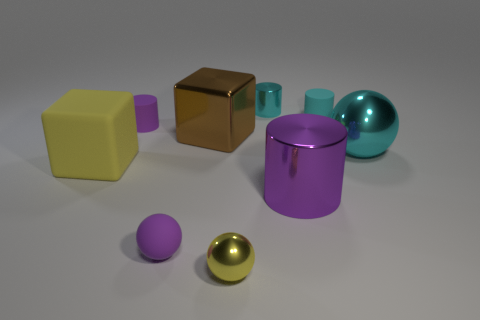Subtract all metal spheres. How many spheres are left? 1 Subtract 1 spheres. How many spheres are left? 2 Add 1 brown shiny spheres. How many objects exist? 10 Subtract all balls. How many objects are left? 6 Subtract all gray cylinders. Subtract all yellow blocks. How many cylinders are left? 4 Subtract 1 purple spheres. How many objects are left? 8 Subtract all cyan rubber things. Subtract all small rubber things. How many objects are left? 5 Add 4 metallic objects. How many metallic objects are left? 9 Add 8 rubber cylinders. How many rubber cylinders exist? 10 